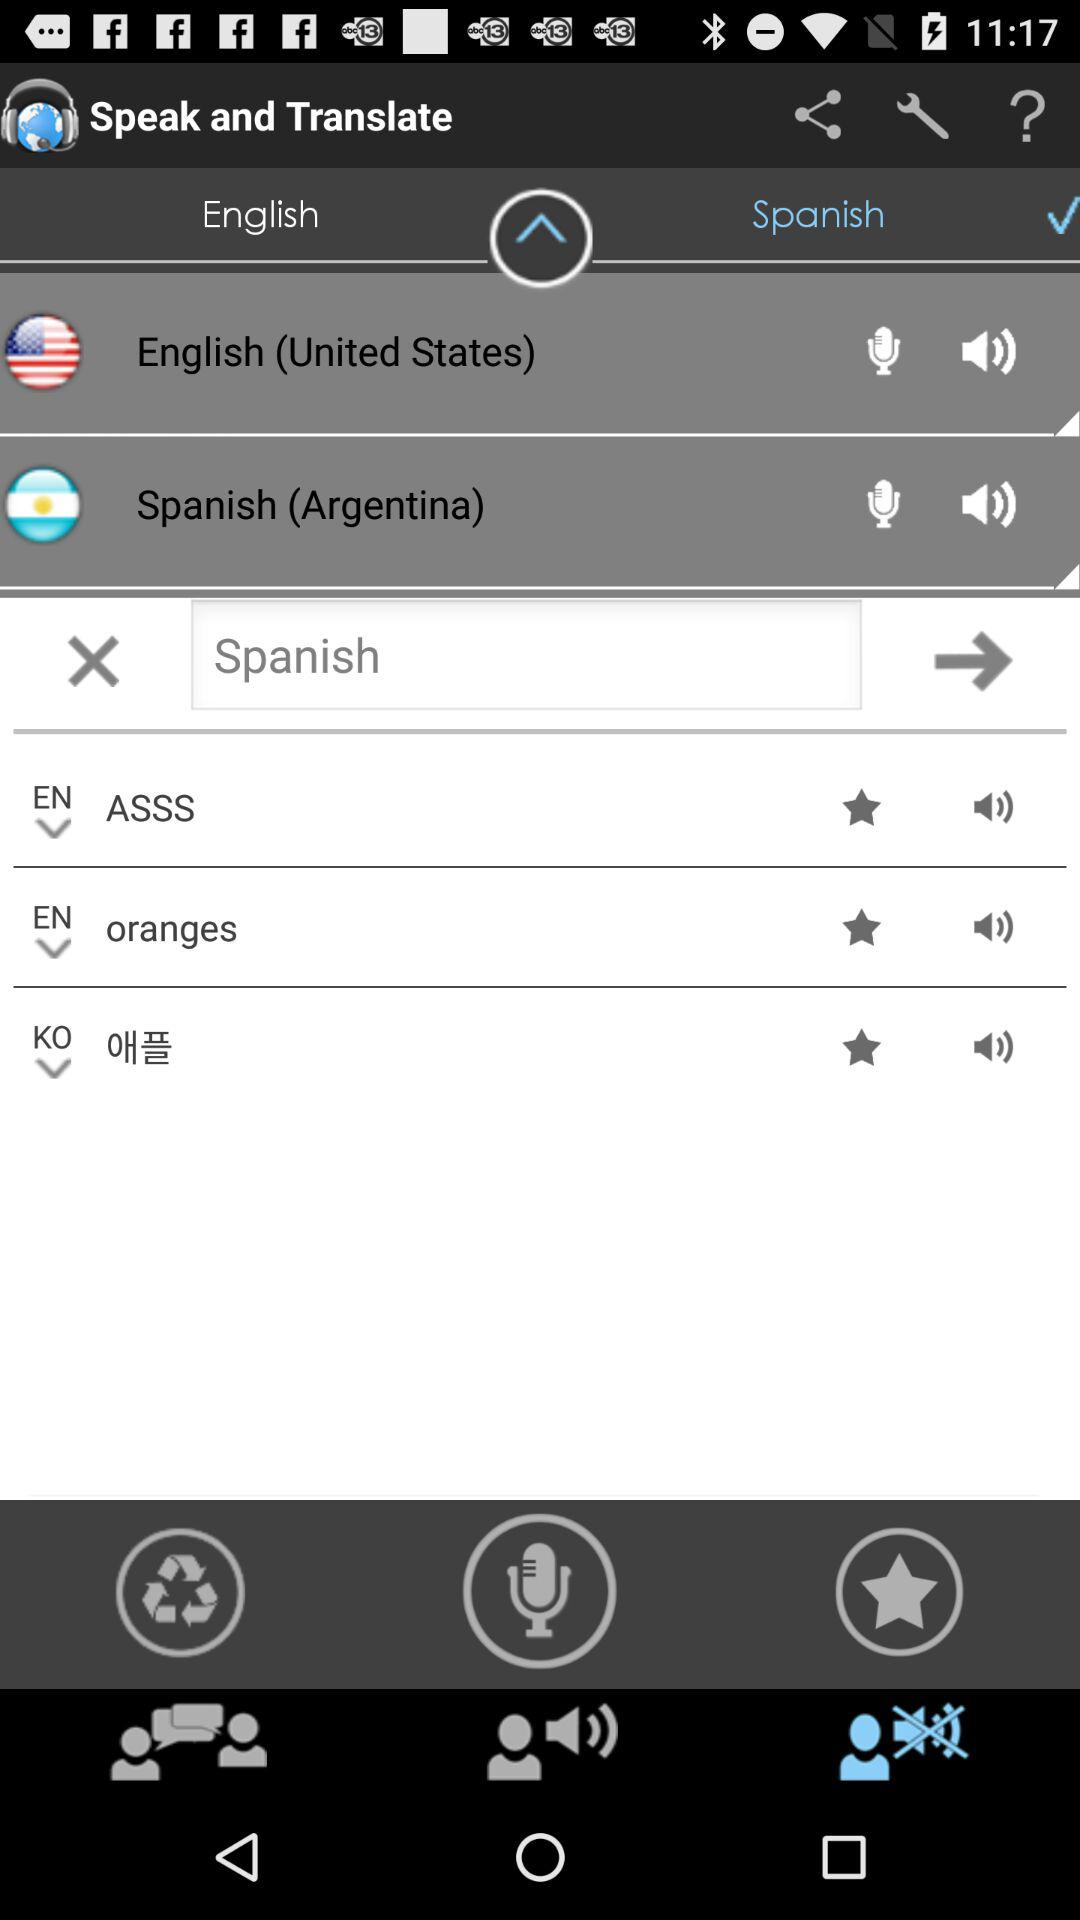What is the app name? The app name is "Speak and Translate". 